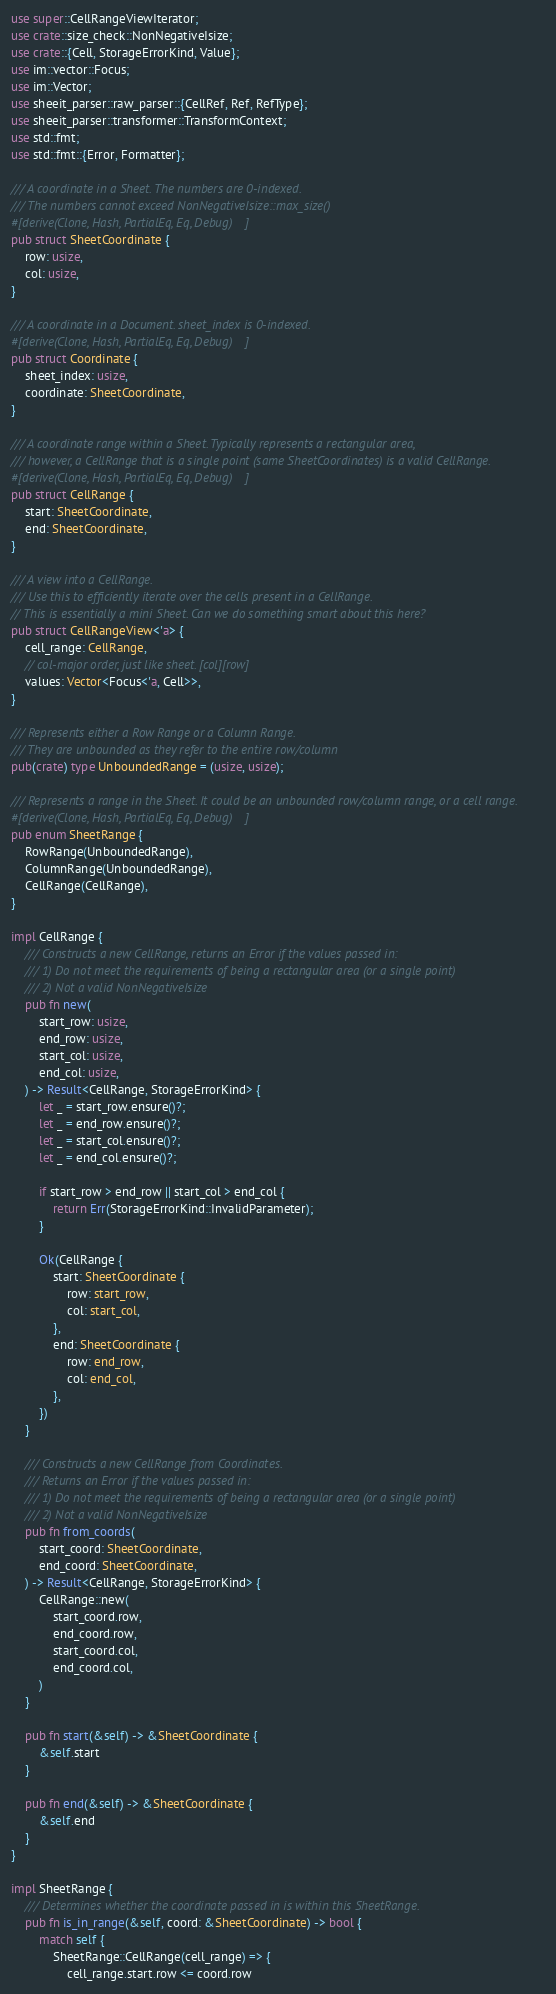Convert code to text. <code><loc_0><loc_0><loc_500><loc_500><_Rust_>use super::CellRangeViewIterator;
use crate::size_check::NonNegativeIsize;
use crate::{Cell, StorageErrorKind, Value};
use im::vector::Focus;
use im::Vector;
use sheeit_parser::raw_parser::{CellRef, Ref, RefType};
use sheeit_parser::transformer::TransformContext;
use std::fmt;
use std::fmt::{Error, Formatter};

/// A coordinate in a Sheet. The numbers are 0-indexed.
/// The numbers cannot exceed NonNegativeIsize::max_size()
#[derive(Clone, Hash, PartialEq, Eq, Debug)]
pub struct SheetCoordinate {
    row: usize,
    col: usize,
}

/// A coordinate in a Document. sheet_index is 0-indexed.
#[derive(Clone, Hash, PartialEq, Eq, Debug)]
pub struct Coordinate {
    sheet_index: usize,
    coordinate: SheetCoordinate,
}

/// A coordinate range within a Sheet. Typically represents a rectangular area,
/// however, a CellRange that is a single point (same SheetCoordinates) is a valid CellRange.
#[derive(Clone, Hash, PartialEq, Eq, Debug)]
pub struct CellRange {
    start: SheetCoordinate,
    end: SheetCoordinate,
}

/// A view into a CellRange.
/// Use this to efficiently iterate over the cells present in a CellRange.
// This is essentially a mini Sheet. Can we do something smart about this here?
pub struct CellRangeView<'a> {
    cell_range: CellRange,
    // col-major order, just like sheet. [col][row]
    values: Vector<Focus<'a, Cell>>,
}

/// Represents either a Row Range or a Column Range.
/// They are unbounded as they refer to the entire row/column
pub(crate) type UnboundedRange = (usize, usize);

/// Represents a range in the Sheet. It could be an unbounded row/column range, or a cell range.
#[derive(Clone, Hash, PartialEq, Eq, Debug)]
pub enum SheetRange {
    RowRange(UnboundedRange),
    ColumnRange(UnboundedRange),
    CellRange(CellRange),
}

impl CellRange {
    /// Constructs a new CellRange, returns an Error if the values passed in:
    /// 1) Do not meet the requirements of being a rectangular area (or a single point)
    /// 2) Not a valid NonNegativeIsize
    pub fn new(
        start_row: usize,
        end_row: usize,
        start_col: usize,
        end_col: usize,
    ) -> Result<CellRange, StorageErrorKind> {
        let _ = start_row.ensure()?;
        let _ = end_row.ensure()?;
        let _ = start_col.ensure()?;
        let _ = end_col.ensure()?;

        if start_row > end_row || start_col > end_col {
            return Err(StorageErrorKind::InvalidParameter);
        }

        Ok(CellRange {
            start: SheetCoordinate {
                row: start_row,
                col: start_col,
            },
            end: SheetCoordinate {
                row: end_row,
                col: end_col,
            },
        })
    }

    /// Constructs a new CellRange from Coordinates.
    /// Returns an Error if the values passed in:
    /// 1) Do not meet the requirements of being a rectangular area (or a single point)
    /// 2) Not a valid NonNegativeIsize
    pub fn from_coords(
        start_coord: SheetCoordinate,
        end_coord: SheetCoordinate,
    ) -> Result<CellRange, StorageErrorKind> {
        CellRange::new(
            start_coord.row,
            end_coord.row,
            start_coord.col,
            end_coord.col,
        )
    }

    pub fn start(&self) -> &SheetCoordinate {
        &self.start
    }

    pub fn end(&self) -> &SheetCoordinate {
        &self.end
    }
}

impl SheetRange {
    /// Determines whether the coordinate passed in is within this SheetRange.
    pub fn is_in_range(&self, coord: &SheetCoordinate) -> bool {
        match self {
            SheetRange::CellRange(cell_range) => {
                cell_range.start.row <= coord.row</code> 